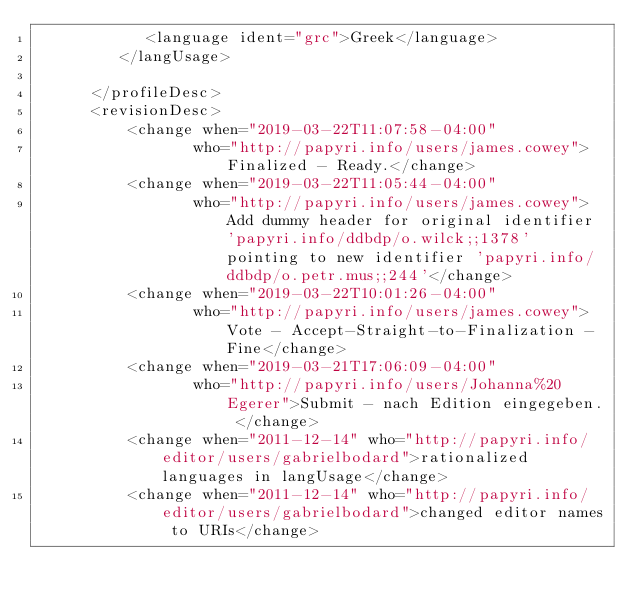<code> <loc_0><loc_0><loc_500><loc_500><_XML_>            <language ident="grc">Greek</language>
         </langUsage>
         
      </profileDesc>
      <revisionDesc>
          <change when="2019-03-22T11:07:58-04:00"
                 who="http://papyri.info/users/james.cowey">Finalized - Ready.</change>
          <change when="2019-03-22T11:05:44-04:00"
                 who="http://papyri.info/users/james.cowey">Add dummy header for original identifier 'papyri.info/ddbdp/o.wilck;;1378' pointing to new identifier 'papyri.info/ddbdp/o.petr.mus;;244'</change>
          <change when="2019-03-22T10:01:26-04:00"
                 who="http://papyri.info/users/james.cowey">Vote - Accept-Straight-to-Finalization - Fine</change>
          <change when="2019-03-21T17:06:09-04:00"
                 who="http://papyri.info/users/Johanna%20Egerer">Submit - nach Edition eingegeben. </change>
          <change when="2011-12-14" who="http://papyri.info/editor/users/gabrielbodard">rationalized languages in langUsage</change>
          <change when="2011-12-14" who="http://papyri.info/editor/users/gabrielbodard">changed editor names to URIs</change></code> 